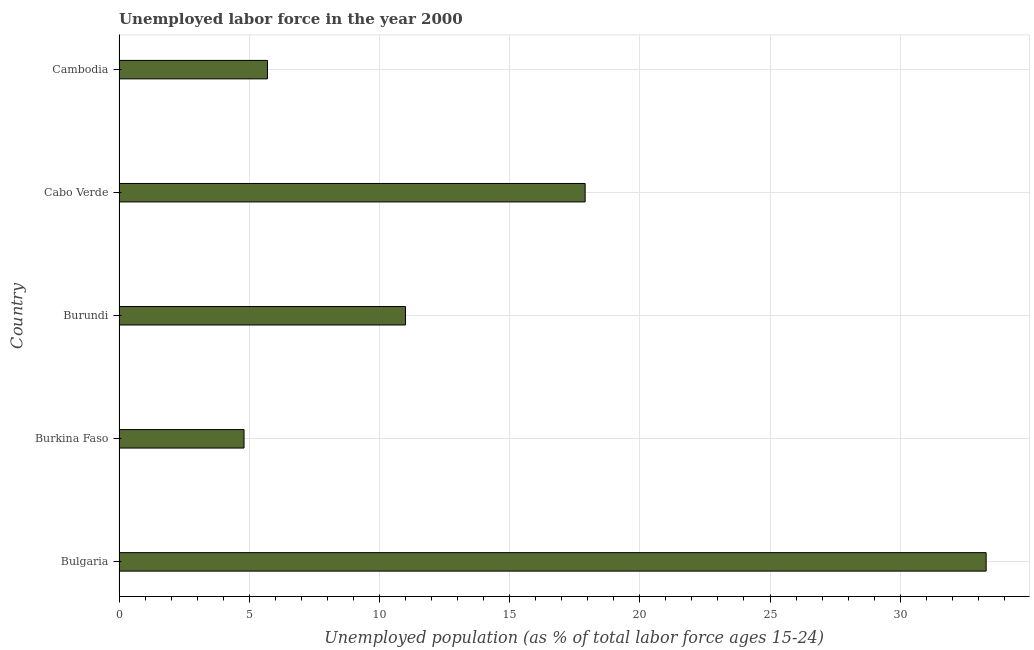Does the graph contain grids?
Make the answer very short. Yes. What is the title of the graph?
Ensure brevity in your answer.  Unemployed labor force in the year 2000. What is the label or title of the X-axis?
Your answer should be very brief. Unemployed population (as % of total labor force ages 15-24). What is the total unemployed youth population in Burkina Faso?
Your response must be concise. 4.8. Across all countries, what is the maximum total unemployed youth population?
Keep it short and to the point. 33.3. Across all countries, what is the minimum total unemployed youth population?
Your answer should be very brief. 4.8. In which country was the total unemployed youth population minimum?
Offer a terse response. Burkina Faso. What is the sum of the total unemployed youth population?
Give a very brief answer. 72.7. What is the average total unemployed youth population per country?
Offer a terse response. 14.54. What is the median total unemployed youth population?
Your response must be concise. 11. In how many countries, is the total unemployed youth population greater than 18 %?
Ensure brevity in your answer.  1. What is the ratio of the total unemployed youth population in Bulgaria to that in Cambodia?
Offer a terse response. 5.84. What is the difference between the highest and the second highest total unemployed youth population?
Give a very brief answer. 15.4. Is the sum of the total unemployed youth population in Cabo Verde and Cambodia greater than the maximum total unemployed youth population across all countries?
Provide a short and direct response. No. In how many countries, is the total unemployed youth population greater than the average total unemployed youth population taken over all countries?
Give a very brief answer. 2. How many countries are there in the graph?
Provide a succinct answer. 5. What is the difference between two consecutive major ticks on the X-axis?
Keep it short and to the point. 5. What is the Unemployed population (as % of total labor force ages 15-24) in Bulgaria?
Keep it short and to the point. 33.3. What is the Unemployed population (as % of total labor force ages 15-24) in Burkina Faso?
Keep it short and to the point. 4.8. What is the Unemployed population (as % of total labor force ages 15-24) in Burundi?
Your answer should be compact. 11. What is the Unemployed population (as % of total labor force ages 15-24) of Cabo Verde?
Your answer should be compact. 17.9. What is the Unemployed population (as % of total labor force ages 15-24) of Cambodia?
Your response must be concise. 5.7. What is the difference between the Unemployed population (as % of total labor force ages 15-24) in Bulgaria and Burundi?
Offer a terse response. 22.3. What is the difference between the Unemployed population (as % of total labor force ages 15-24) in Bulgaria and Cambodia?
Your response must be concise. 27.6. What is the difference between the Unemployed population (as % of total labor force ages 15-24) in Burkina Faso and Cambodia?
Offer a very short reply. -0.9. What is the ratio of the Unemployed population (as % of total labor force ages 15-24) in Bulgaria to that in Burkina Faso?
Your response must be concise. 6.94. What is the ratio of the Unemployed population (as % of total labor force ages 15-24) in Bulgaria to that in Burundi?
Provide a succinct answer. 3.03. What is the ratio of the Unemployed population (as % of total labor force ages 15-24) in Bulgaria to that in Cabo Verde?
Give a very brief answer. 1.86. What is the ratio of the Unemployed population (as % of total labor force ages 15-24) in Bulgaria to that in Cambodia?
Your answer should be compact. 5.84. What is the ratio of the Unemployed population (as % of total labor force ages 15-24) in Burkina Faso to that in Burundi?
Your answer should be very brief. 0.44. What is the ratio of the Unemployed population (as % of total labor force ages 15-24) in Burkina Faso to that in Cabo Verde?
Provide a short and direct response. 0.27. What is the ratio of the Unemployed population (as % of total labor force ages 15-24) in Burkina Faso to that in Cambodia?
Your answer should be very brief. 0.84. What is the ratio of the Unemployed population (as % of total labor force ages 15-24) in Burundi to that in Cabo Verde?
Offer a very short reply. 0.61. What is the ratio of the Unemployed population (as % of total labor force ages 15-24) in Burundi to that in Cambodia?
Offer a terse response. 1.93. What is the ratio of the Unemployed population (as % of total labor force ages 15-24) in Cabo Verde to that in Cambodia?
Keep it short and to the point. 3.14. 